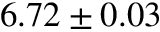Convert formula to latex. <formula><loc_0><loc_0><loc_500><loc_500>6 . 7 2 \pm 0 . 0 3</formula> 